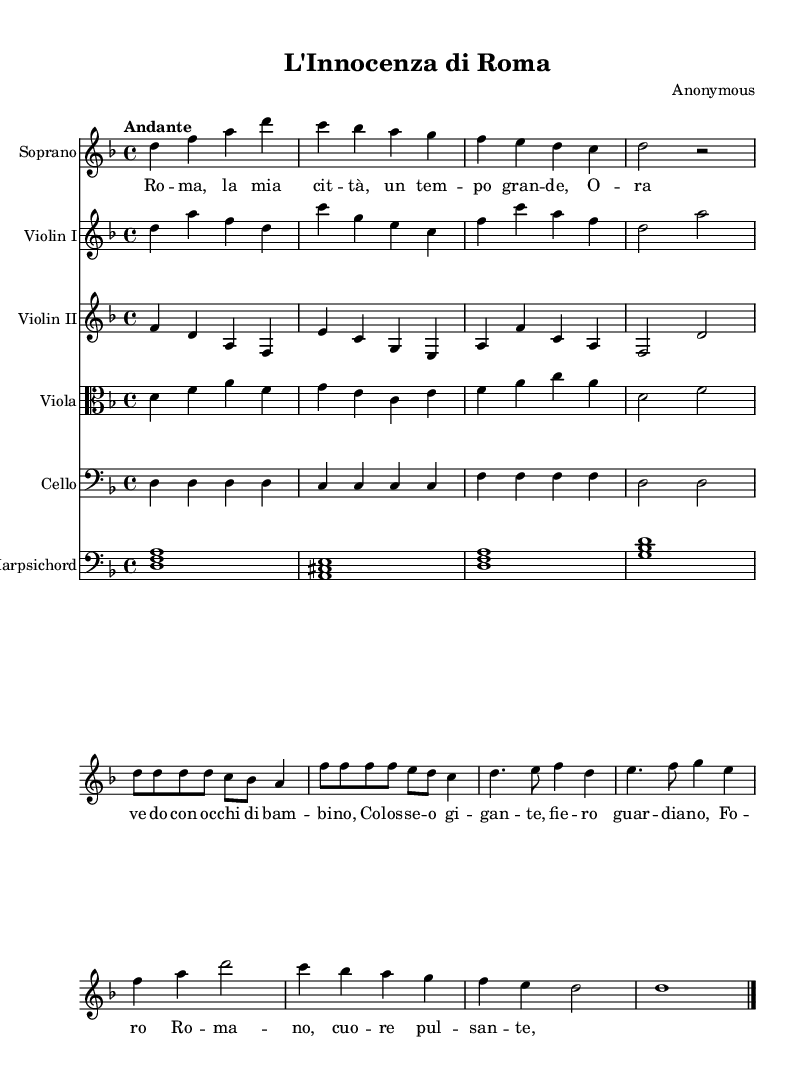What is the key signature of this music? The key signature is indicated by the 'key d minor' at the beginning of the global section of the music. This means there are one flat (B flat) in the key signature.
Answer: D minor What is the time signature of this music? The time signature is specified as '4/4' in the global section of the music, indicating four beats per measure with a quarter note getting one beat.
Answer: 4/4 What is the tempo indicated for the piece? The tempo marking of "Andante" is found in the global section, suggesting that the piece should be played at a moderately slow tempo.
Answer: Andante How many voices are present in the score? The score includes a Soprano, Violin I, Violin II, Viola, Cello, and Harpsichord, totaling six distinct voices or instrument parts.
Answer: Six What type of musical piece is this? The header of the score describes it as an "Oratorio," which is a large musical composition for orchestra, choir, and soloists, typically on a religious theme.
Answer: Oratorio What historical perspective does the text provide? The text reflects a child's perspective on Rome, capturing innocence and a sense of wonder, as indicated by the lyrics expressing admiration for Rome and its grandeur through innocent eyes.
Answer: A child's perspective Which instruments are classified as strings in this score? The instruments categorized as strings in this piece include Violin I, Violin II, Viola, and Cello, all of which play the stringed ensemble parts.
Answer: Violin I, Violin II, Viola, Cello 